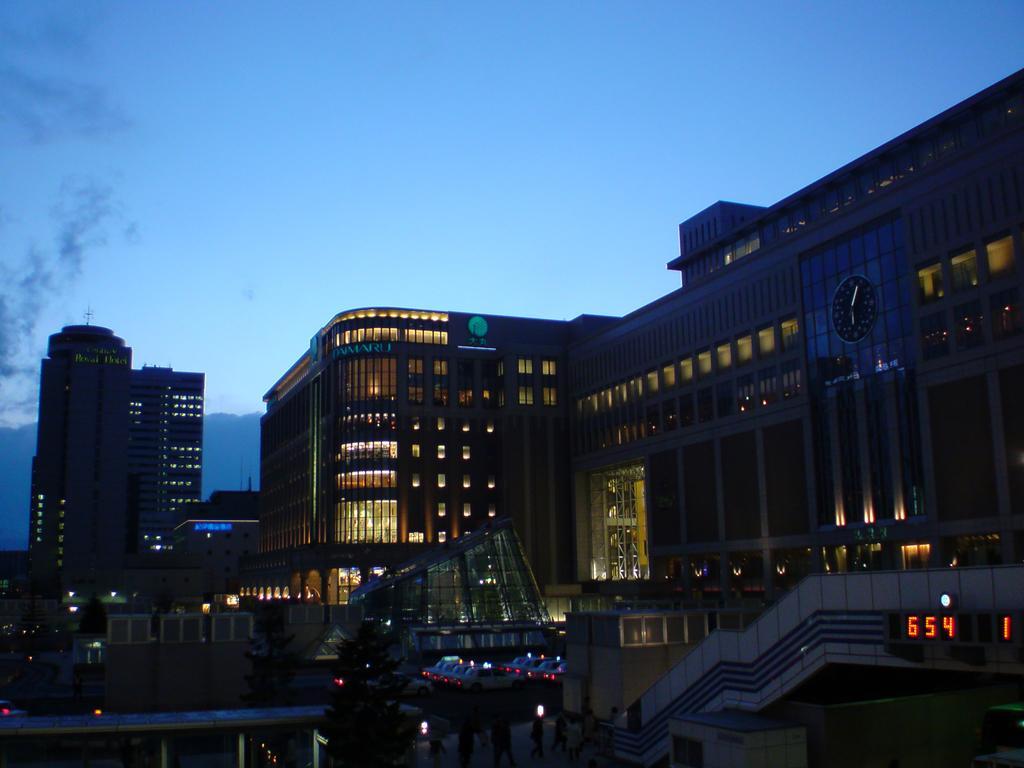In one or two sentences, can you explain what this image depicts? In the picture I can see tower buildings, vehicles parked here, trees, LED display board, lights and the dark sky in the background. 